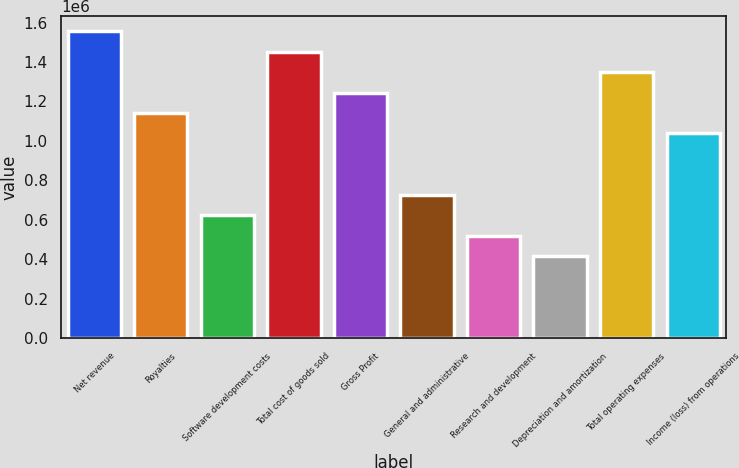Convert chart. <chart><loc_0><loc_0><loc_500><loc_500><bar_chart><fcel>Net revenue<fcel>Royalties<fcel>Software development costs<fcel>Total cost of goods sold<fcel>Gross Profit<fcel>General and administrative<fcel>Research and development<fcel>Depreciation and amortization<fcel>Total operating expenses<fcel>Income (loss) from operations<nl><fcel>1.55676e+06<fcel>1.14162e+06<fcel>622705<fcel>1.45297e+06<fcel>1.24541e+06<fcel>726489<fcel>518921<fcel>415138<fcel>1.34919e+06<fcel>1.03784e+06<nl></chart> 